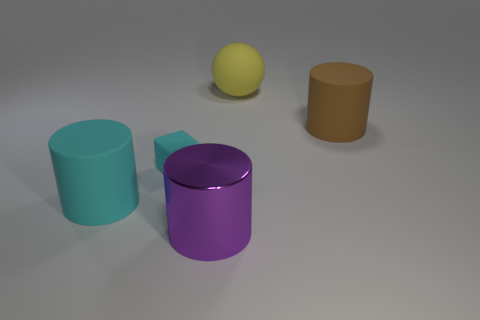Subtract all big rubber cylinders. How many cylinders are left? 1 Subtract all purple cylinders. How many cylinders are left? 2 Subtract all spheres. How many objects are left? 4 Subtract 1 balls. How many balls are left? 0 Subtract all blue cylinders. Subtract all purple cubes. How many cylinders are left? 3 Subtract all yellow cylinders. How many cyan spheres are left? 0 Subtract all large purple cylinders. Subtract all brown cylinders. How many objects are left? 3 Add 2 rubber balls. How many rubber balls are left? 3 Add 4 green things. How many green things exist? 4 Add 5 green rubber things. How many objects exist? 10 